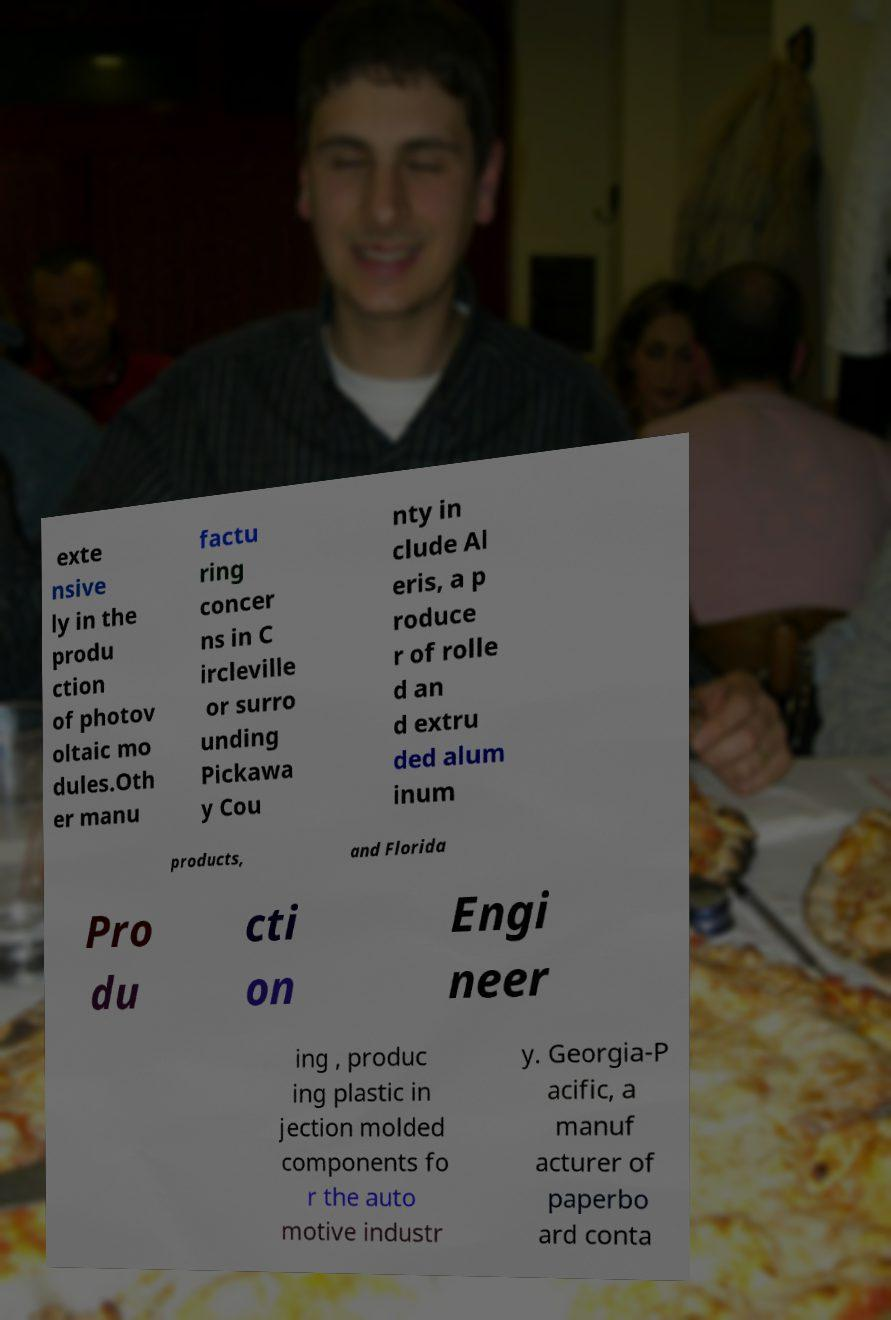What messages or text are displayed in this image? I need them in a readable, typed format. exte nsive ly in the produ ction of photov oltaic mo dules.Oth er manu factu ring concer ns in C ircleville or surro unding Pickawa y Cou nty in clude Al eris, a p roduce r of rolle d an d extru ded alum inum products, and Florida Pro du cti on Engi neer ing , produc ing plastic in jection molded components fo r the auto motive industr y. Georgia-P acific, a manuf acturer of paperbo ard conta 